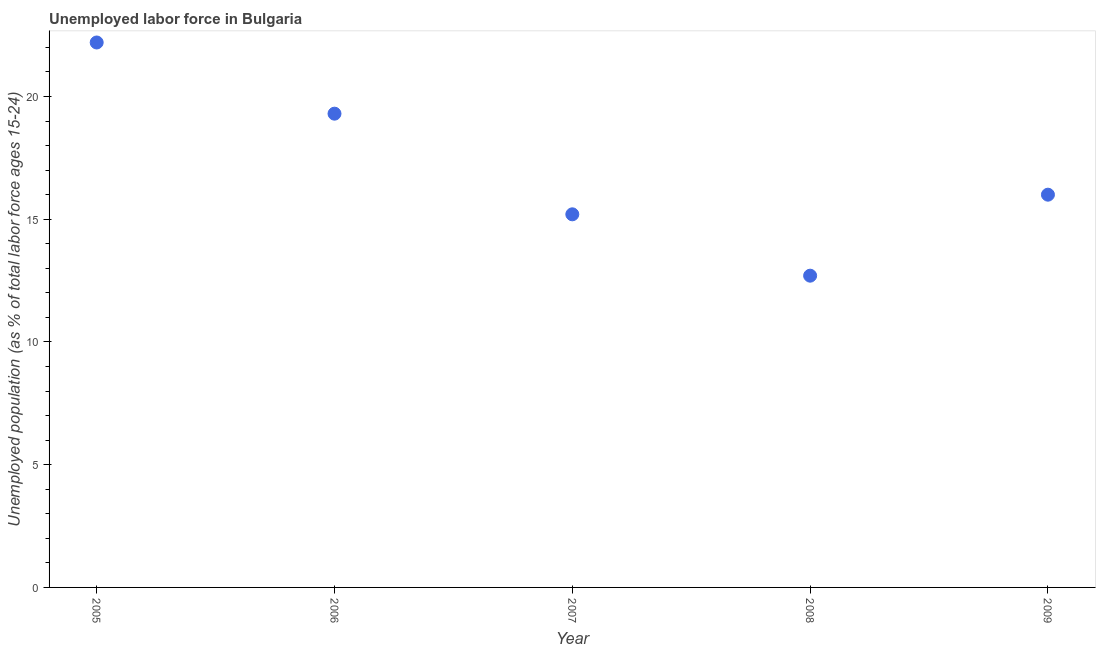Across all years, what is the maximum total unemployed youth population?
Your answer should be compact. 22.2. Across all years, what is the minimum total unemployed youth population?
Provide a short and direct response. 12.7. In which year was the total unemployed youth population maximum?
Your response must be concise. 2005. What is the sum of the total unemployed youth population?
Your answer should be compact. 85.4. What is the difference between the total unemployed youth population in 2007 and 2009?
Provide a short and direct response. -0.8. What is the average total unemployed youth population per year?
Provide a succinct answer. 17.08. What is the median total unemployed youth population?
Offer a terse response. 16. In how many years, is the total unemployed youth population greater than 8 %?
Keep it short and to the point. 5. What is the ratio of the total unemployed youth population in 2008 to that in 2009?
Provide a short and direct response. 0.79. What is the difference between the highest and the second highest total unemployed youth population?
Provide a succinct answer. 2.9. What is the difference between the highest and the lowest total unemployed youth population?
Offer a terse response. 9.5. How many years are there in the graph?
Your response must be concise. 5. Are the values on the major ticks of Y-axis written in scientific E-notation?
Offer a very short reply. No. Does the graph contain any zero values?
Your response must be concise. No. Does the graph contain grids?
Provide a succinct answer. No. What is the title of the graph?
Provide a short and direct response. Unemployed labor force in Bulgaria. What is the label or title of the X-axis?
Offer a very short reply. Year. What is the label or title of the Y-axis?
Keep it short and to the point. Unemployed population (as % of total labor force ages 15-24). What is the Unemployed population (as % of total labor force ages 15-24) in 2005?
Your answer should be very brief. 22.2. What is the Unemployed population (as % of total labor force ages 15-24) in 2006?
Provide a succinct answer. 19.3. What is the Unemployed population (as % of total labor force ages 15-24) in 2007?
Offer a terse response. 15.2. What is the Unemployed population (as % of total labor force ages 15-24) in 2008?
Your answer should be compact. 12.7. What is the difference between the Unemployed population (as % of total labor force ages 15-24) in 2005 and 2006?
Offer a very short reply. 2.9. What is the difference between the Unemployed population (as % of total labor force ages 15-24) in 2005 and 2007?
Your answer should be compact. 7. What is the difference between the Unemployed population (as % of total labor force ages 15-24) in 2005 and 2008?
Provide a succinct answer. 9.5. What is the difference between the Unemployed population (as % of total labor force ages 15-24) in 2006 and 2008?
Ensure brevity in your answer.  6.6. What is the difference between the Unemployed population (as % of total labor force ages 15-24) in 2006 and 2009?
Offer a terse response. 3.3. What is the difference between the Unemployed population (as % of total labor force ages 15-24) in 2007 and 2009?
Ensure brevity in your answer.  -0.8. What is the difference between the Unemployed population (as % of total labor force ages 15-24) in 2008 and 2009?
Make the answer very short. -3.3. What is the ratio of the Unemployed population (as % of total labor force ages 15-24) in 2005 to that in 2006?
Give a very brief answer. 1.15. What is the ratio of the Unemployed population (as % of total labor force ages 15-24) in 2005 to that in 2007?
Your answer should be compact. 1.46. What is the ratio of the Unemployed population (as % of total labor force ages 15-24) in 2005 to that in 2008?
Give a very brief answer. 1.75. What is the ratio of the Unemployed population (as % of total labor force ages 15-24) in 2005 to that in 2009?
Your response must be concise. 1.39. What is the ratio of the Unemployed population (as % of total labor force ages 15-24) in 2006 to that in 2007?
Keep it short and to the point. 1.27. What is the ratio of the Unemployed population (as % of total labor force ages 15-24) in 2006 to that in 2008?
Give a very brief answer. 1.52. What is the ratio of the Unemployed population (as % of total labor force ages 15-24) in 2006 to that in 2009?
Provide a succinct answer. 1.21. What is the ratio of the Unemployed population (as % of total labor force ages 15-24) in 2007 to that in 2008?
Your answer should be compact. 1.2. What is the ratio of the Unemployed population (as % of total labor force ages 15-24) in 2008 to that in 2009?
Your answer should be compact. 0.79. 